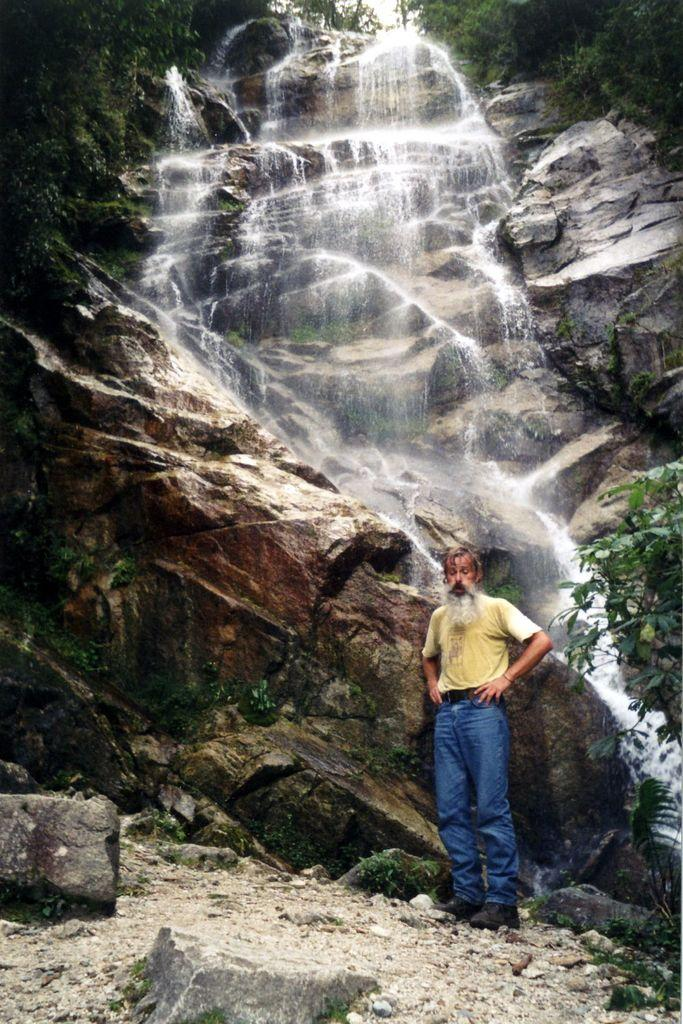Who is the main subject in the image? There is an old man in the image. What is the old man's position in relation to the hill? The old man is standing in front of a hill. What natural feature can be seen on the hill? There is a waterfall flowing on the hill. What can be seen on the right side of the image? There is a plant on the right side of the image. What type of quartz can be seen on the old man's plate in the image? There is no quartz or plate present in the image. Is the old man wearing a chain around his neck in the image? There is no chain visible around the old man's neck in the image. 